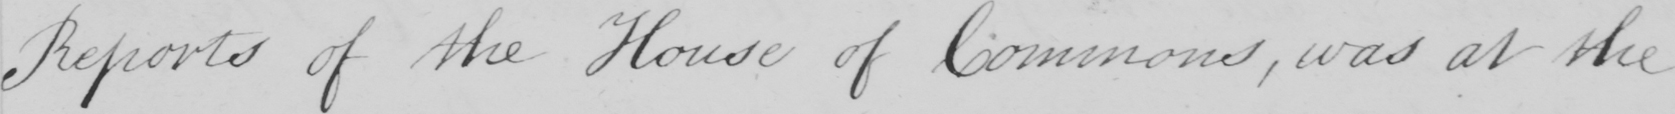Please provide the text content of this handwritten line. Reports of the House of Commons , was at the 